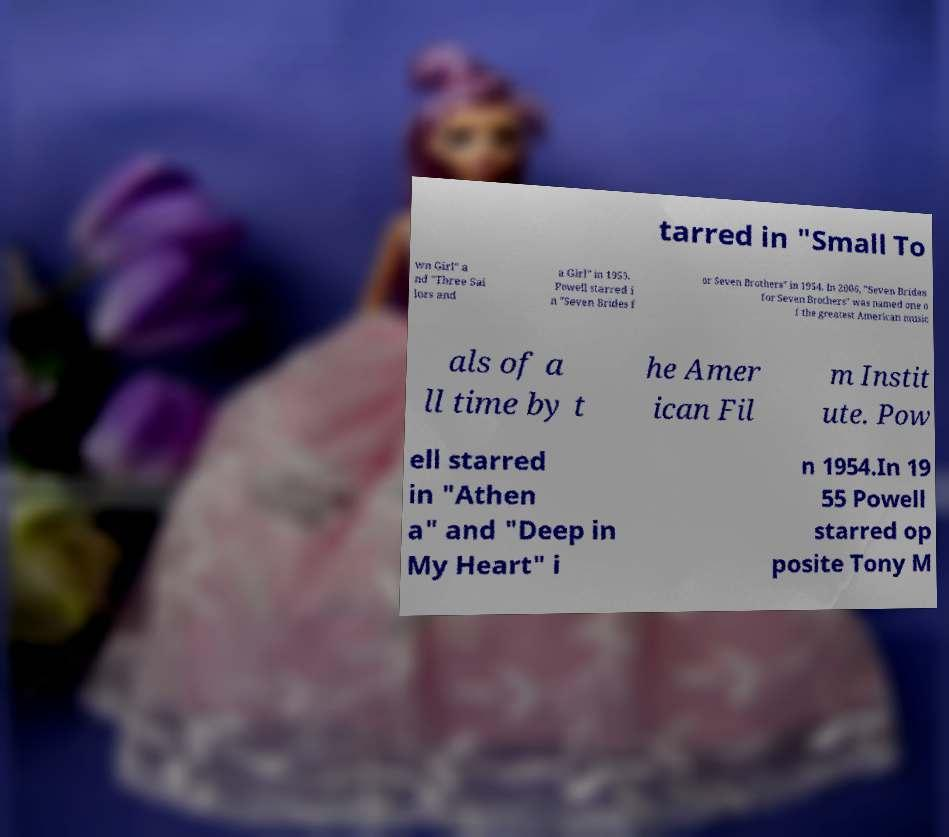Please identify and transcribe the text found in this image. tarred in "Small To wn Girl" a nd "Three Sai lors and a Girl" in 1953. Powell starred i n "Seven Brides f or Seven Brothers" in 1954. In 2006, "Seven Brides for Seven Brothers" was named one o f the greatest American music als of a ll time by t he Amer ican Fil m Instit ute. Pow ell starred in "Athen a" and "Deep in My Heart" i n 1954.In 19 55 Powell starred op posite Tony M 